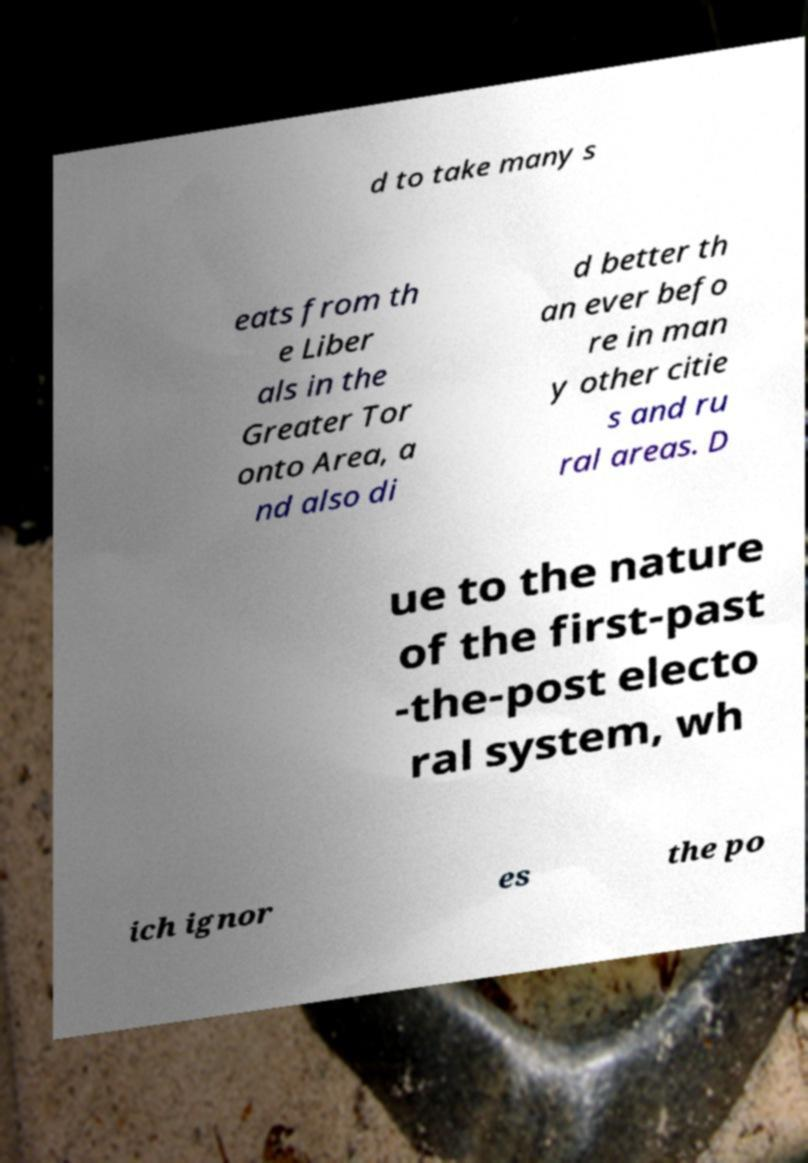Can you read and provide the text displayed in the image?This photo seems to have some interesting text. Can you extract and type it out for me? d to take many s eats from th e Liber als in the Greater Tor onto Area, a nd also di d better th an ever befo re in man y other citie s and ru ral areas. D ue to the nature of the first-past -the-post electo ral system, wh ich ignor es the po 